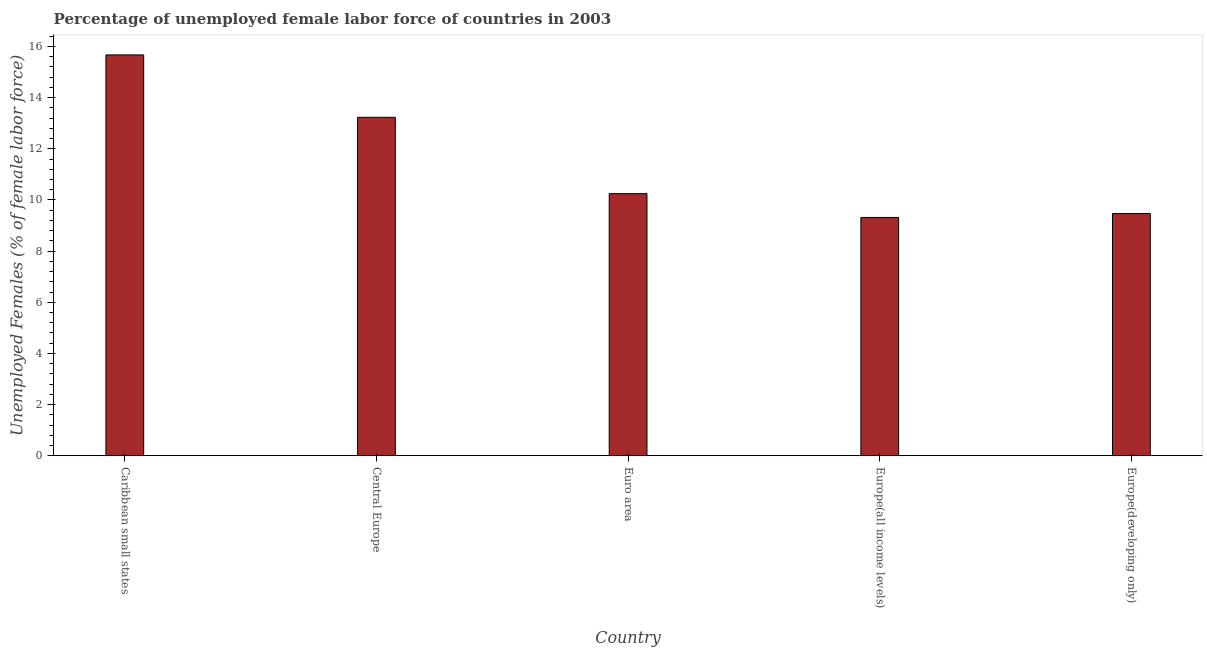Does the graph contain any zero values?
Ensure brevity in your answer.  No. What is the title of the graph?
Your answer should be compact. Percentage of unemployed female labor force of countries in 2003. What is the label or title of the Y-axis?
Provide a short and direct response. Unemployed Females (% of female labor force). What is the total unemployed female labour force in Central Europe?
Provide a succinct answer. 13.23. Across all countries, what is the maximum total unemployed female labour force?
Ensure brevity in your answer.  15.67. Across all countries, what is the minimum total unemployed female labour force?
Provide a short and direct response. 9.32. In which country was the total unemployed female labour force maximum?
Keep it short and to the point. Caribbean small states. In which country was the total unemployed female labour force minimum?
Make the answer very short. Europe(all income levels). What is the sum of the total unemployed female labour force?
Give a very brief answer. 57.94. What is the difference between the total unemployed female labour force in Central Europe and Euro area?
Keep it short and to the point. 2.98. What is the average total unemployed female labour force per country?
Ensure brevity in your answer.  11.59. What is the median total unemployed female labour force?
Keep it short and to the point. 10.25. What is the ratio of the total unemployed female labour force in Central Europe to that in Europe(developing only)?
Your response must be concise. 1.4. Is the total unemployed female labour force in Central Europe less than that in Europe(developing only)?
Provide a short and direct response. No. Is the difference between the total unemployed female labour force in Euro area and Europe(all income levels) greater than the difference between any two countries?
Keep it short and to the point. No. What is the difference between the highest and the second highest total unemployed female labour force?
Offer a very short reply. 2.44. What is the difference between the highest and the lowest total unemployed female labour force?
Provide a short and direct response. 6.36. What is the difference between two consecutive major ticks on the Y-axis?
Offer a terse response. 2. What is the Unemployed Females (% of female labor force) of Caribbean small states?
Offer a terse response. 15.67. What is the Unemployed Females (% of female labor force) in Central Europe?
Your response must be concise. 13.23. What is the Unemployed Females (% of female labor force) in Euro area?
Your answer should be compact. 10.25. What is the Unemployed Females (% of female labor force) in Europe(all income levels)?
Offer a very short reply. 9.32. What is the Unemployed Females (% of female labor force) of Europe(developing only)?
Provide a short and direct response. 9.47. What is the difference between the Unemployed Females (% of female labor force) in Caribbean small states and Central Europe?
Ensure brevity in your answer.  2.44. What is the difference between the Unemployed Females (% of female labor force) in Caribbean small states and Euro area?
Your response must be concise. 5.42. What is the difference between the Unemployed Females (% of female labor force) in Caribbean small states and Europe(all income levels)?
Your answer should be very brief. 6.36. What is the difference between the Unemployed Females (% of female labor force) in Caribbean small states and Europe(developing only)?
Keep it short and to the point. 6.2. What is the difference between the Unemployed Females (% of female labor force) in Central Europe and Euro area?
Provide a short and direct response. 2.98. What is the difference between the Unemployed Females (% of female labor force) in Central Europe and Europe(all income levels)?
Give a very brief answer. 3.92. What is the difference between the Unemployed Females (% of female labor force) in Central Europe and Europe(developing only)?
Your answer should be compact. 3.76. What is the difference between the Unemployed Females (% of female labor force) in Euro area and Europe(all income levels)?
Give a very brief answer. 0.93. What is the difference between the Unemployed Females (% of female labor force) in Euro area and Europe(developing only)?
Provide a succinct answer. 0.78. What is the difference between the Unemployed Females (% of female labor force) in Europe(all income levels) and Europe(developing only)?
Offer a terse response. -0.15. What is the ratio of the Unemployed Females (% of female labor force) in Caribbean small states to that in Central Europe?
Your response must be concise. 1.18. What is the ratio of the Unemployed Females (% of female labor force) in Caribbean small states to that in Euro area?
Your answer should be very brief. 1.53. What is the ratio of the Unemployed Females (% of female labor force) in Caribbean small states to that in Europe(all income levels)?
Keep it short and to the point. 1.68. What is the ratio of the Unemployed Females (% of female labor force) in Caribbean small states to that in Europe(developing only)?
Keep it short and to the point. 1.66. What is the ratio of the Unemployed Females (% of female labor force) in Central Europe to that in Euro area?
Provide a succinct answer. 1.29. What is the ratio of the Unemployed Females (% of female labor force) in Central Europe to that in Europe(all income levels)?
Your answer should be very brief. 1.42. What is the ratio of the Unemployed Females (% of female labor force) in Central Europe to that in Europe(developing only)?
Your answer should be compact. 1.4. What is the ratio of the Unemployed Females (% of female labor force) in Euro area to that in Europe(all income levels)?
Offer a terse response. 1.1. What is the ratio of the Unemployed Females (% of female labor force) in Euro area to that in Europe(developing only)?
Your answer should be compact. 1.08. 